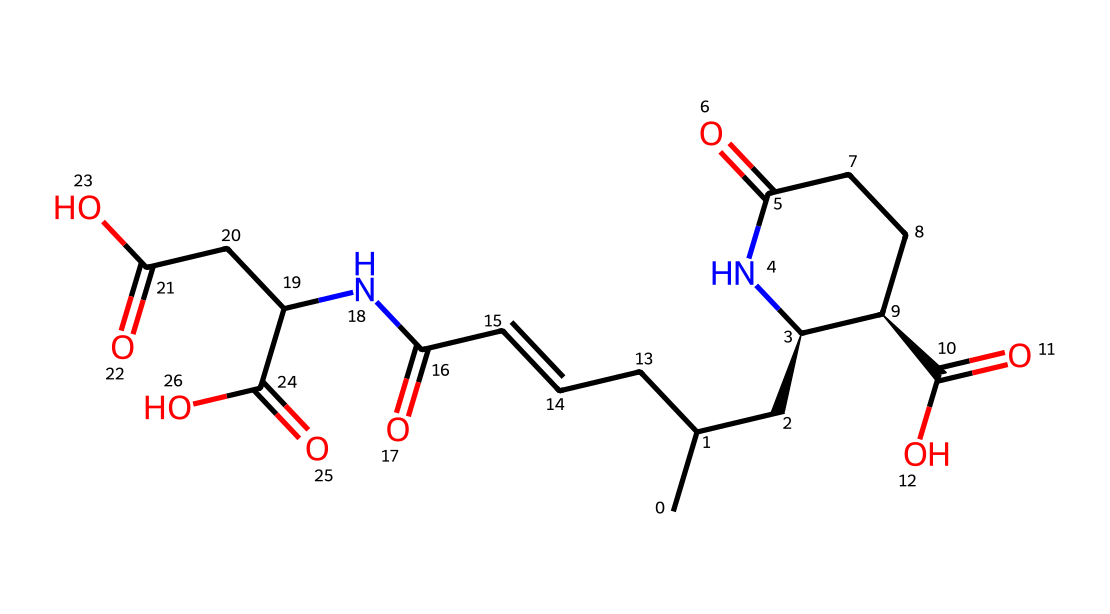How many rings are present in the structure? The SMILES representation indicates that there is a cyclic component in the structure when observing the bracketed sections, specifically after the 'C' atoms and the nitrogen (N) indicating a ring. Counting reveals there is one ring structure.
Answer: one What is the primary functional group present in this molecule? Upon analyzing the structure, the presence of the carboxylic acid (-COOH) functional groups can be identified, as seen in the segments that conclude with 'C(=O)O.' This is the most prominent functional group in the molecule.
Answer: carboxylic acid What is the total number of nitrogen atoms in the molecule? By examining the SMILES, there is one nitrogen atom present. This is identified by looking for 'N' in the representation, confirming its presence in the cyclic structure.
Answer: one Which atoms contribute to the acidity of this compound? The carboxylic acid groups are the main contributors to the acidity, characterized by the presence of the -COOH functional groups that can donate protons. The acidic nature arises from the hydrogens in these groups.
Answer: carboxylic acid hydrogens How many carbon atoms are in domoic acid? By counting each carbon ('C') directly in the SMILES string, a total of 13 carbon atoms are present in the representation, which constitute the backbone and structure of the compound.
Answer: thirteen What type of compound is domoic acid classified as? This compound is categorized as an amino acid due to the presence of both carboxylic acid and amine (the nitrogen in the ring) functional groups. The identifiable groups indicate its role as a natural product and amino acid.
Answer: amino acid What is the significance of the double bonds in this molecule? The double bonds identified by the '/C=C/' indicate unsaturation in the fatty chain of the molecule, which can influence its reactivity and biological interactions, making it more versatile in terms of function and behavior in biological systems.
Answer: unsaturation 